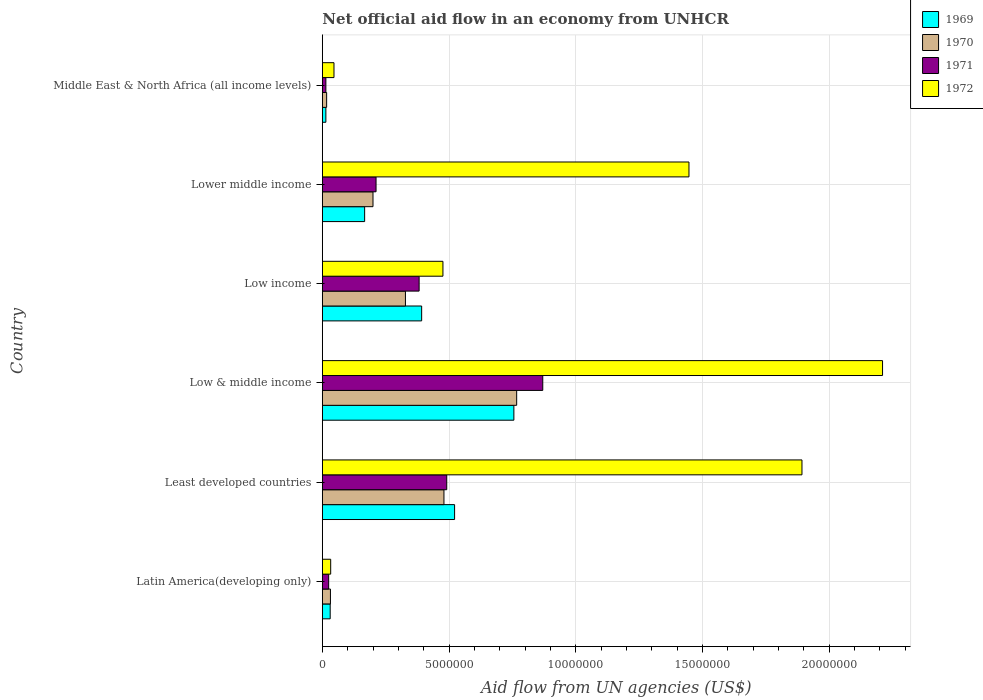How many different coloured bars are there?
Keep it short and to the point. 4. How many bars are there on the 6th tick from the bottom?
Give a very brief answer. 4. What is the label of the 1st group of bars from the top?
Your response must be concise. Middle East & North Africa (all income levels). In how many cases, is the number of bars for a given country not equal to the number of legend labels?
Offer a very short reply. 0. What is the net official aid flow in 1971 in Least developed countries?
Your response must be concise. 4.91e+06. Across all countries, what is the maximum net official aid flow in 1971?
Your answer should be very brief. 8.70e+06. In which country was the net official aid flow in 1972 maximum?
Ensure brevity in your answer.  Low & middle income. In which country was the net official aid flow in 1969 minimum?
Ensure brevity in your answer.  Middle East & North Africa (all income levels). What is the total net official aid flow in 1969 in the graph?
Keep it short and to the point. 1.88e+07. What is the difference between the net official aid flow in 1969 in Low & middle income and that in Lower middle income?
Make the answer very short. 5.89e+06. What is the difference between the net official aid flow in 1970 in Least developed countries and the net official aid flow in 1972 in Low & middle income?
Keep it short and to the point. -1.73e+07. What is the average net official aid flow in 1972 per country?
Ensure brevity in your answer.  1.02e+07. What is the difference between the net official aid flow in 1972 and net official aid flow in 1970 in Low income?
Offer a terse response. 1.48e+06. What is the ratio of the net official aid flow in 1969 in Low & middle income to that in Lower middle income?
Make the answer very short. 4.53. What is the difference between the highest and the second highest net official aid flow in 1971?
Provide a succinct answer. 3.79e+06. What is the difference between the highest and the lowest net official aid flow in 1970?
Provide a short and direct response. 7.50e+06. In how many countries, is the net official aid flow in 1971 greater than the average net official aid flow in 1971 taken over all countries?
Your answer should be very brief. 3. What does the 1st bar from the bottom in Lower middle income represents?
Give a very brief answer. 1969. Is it the case that in every country, the sum of the net official aid flow in 1970 and net official aid flow in 1971 is greater than the net official aid flow in 1969?
Your answer should be compact. Yes. How many bars are there?
Provide a succinct answer. 24. Are all the bars in the graph horizontal?
Provide a short and direct response. Yes. What is the difference between two consecutive major ticks on the X-axis?
Make the answer very short. 5.00e+06. Are the values on the major ticks of X-axis written in scientific E-notation?
Your answer should be very brief. No. Does the graph contain any zero values?
Ensure brevity in your answer.  No. How are the legend labels stacked?
Offer a very short reply. Vertical. What is the title of the graph?
Your answer should be very brief. Net official aid flow in an economy from UNHCR. What is the label or title of the X-axis?
Offer a terse response. Aid flow from UN agencies (US$). What is the label or title of the Y-axis?
Give a very brief answer. Country. What is the Aid flow from UN agencies (US$) in 1970 in Latin America(developing only)?
Your response must be concise. 3.20e+05. What is the Aid flow from UN agencies (US$) in 1971 in Latin America(developing only)?
Provide a succinct answer. 2.50e+05. What is the Aid flow from UN agencies (US$) of 1972 in Latin America(developing only)?
Give a very brief answer. 3.30e+05. What is the Aid flow from UN agencies (US$) in 1969 in Least developed countries?
Make the answer very short. 5.22e+06. What is the Aid flow from UN agencies (US$) of 1970 in Least developed countries?
Offer a terse response. 4.80e+06. What is the Aid flow from UN agencies (US$) of 1971 in Least developed countries?
Provide a short and direct response. 4.91e+06. What is the Aid flow from UN agencies (US$) in 1972 in Least developed countries?
Give a very brief answer. 1.89e+07. What is the Aid flow from UN agencies (US$) in 1969 in Low & middle income?
Your answer should be compact. 7.56e+06. What is the Aid flow from UN agencies (US$) of 1970 in Low & middle income?
Make the answer very short. 7.67e+06. What is the Aid flow from UN agencies (US$) in 1971 in Low & middle income?
Keep it short and to the point. 8.70e+06. What is the Aid flow from UN agencies (US$) of 1972 in Low & middle income?
Your answer should be compact. 2.21e+07. What is the Aid flow from UN agencies (US$) of 1969 in Low income?
Your answer should be very brief. 3.92e+06. What is the Aid flow from UN agencies (US$) of 1970 in Low income?
Make the answer very short. 3.28e+06. What is the Aid flow from UN agencies (US$) in 1971 in Low income?
Ensure brevity in your answer.  3.82e+06. What is the Aid flow from UN agencies (US$) in 1972 in Low income?
Ensure brevity in your answer.  4.76e+06. What is the Aid flow from UN agencies (US$) of 1969 in Lower middle income?
Offer a very short reply. 1.67e+06. What is the Aid flow from UN agencies (US$) in 1970 in Lower middle income?
Your answer should be compact. 2.00e+06. What is the Aid flow from UN agencies (US$) of 1971 in Lower middle income?
Make the answer very short. 2.12e+06. What is the Aid flow from UN agencies (US$) in 1972 in Lower middle income?
Your answer should be very brief. 1.45e+07. What is the Aid flow from UN agencies (US$) in 1969 in Middle East & North Africa (all income levels)?
Keep it short and to the point. 1.40e+05. What is the Aid flow from UN agencies (US$) of 1970 in Middle East & North Africa (all income levels)?
Your answer should be very brief. 1.70e+05. What is the Aid flow from UN agencies (US$) of 1972 in Middle East & North Africa (all income levels)?
Your answer should be compact. 4.60e+05. Across all countries, what is the maximum Aid flow from UN agencies (US$) of 1969?
Keep it short and to the point. 7.56e+06. Across all countries, what is the maximum Aid flow from UN agencies (US$) of 1970?
Your answer should be compact. 7.67e+06. Across all countries, what is the maximum Aid flow from UN agencies (US$) in 1971?
Offer a terse response. 8.70e+06. Across all countries, what is the maximum Aid flow from UN agencies (US$) of 1972?
Offer a terse response. 2.21e+07. Across all countries, what is the minimum Aid flow from UN agencies (US$) of 1969?
Offer a terse response. 1.40e+05. What is the total Aid flow from UN agencies (US$) of 1969 in the graph?
Provide a succinct answer. 1.88e+07. What is the total Aid flow from UN agencies (US$) in 1970 in the graph?
Your response must be concise. 1.82e+07. What is the total Aid flow from UN agencies (US$) of 1971 in the graph?
Keep it short and to the point. 1.99e+07. What is the total Aid flow from UN agencies (US$) in 1972 in the graph?
Offer a terse response. 6.11e+07. What is the difference between the Aid flow from UN agencies (US$) of 1969 in Latin America(developing only) and that in Least developed countries?
Provide a succinct answer. -4.91e+06. What is the difference between the Aid flow from UN agencies (US$) in 1970 in Latin America(developing only) and that in Least developed countries?
Your response must be concise. -4.48e+06. What is the difference between the Aid flow from UN agencies (US$) in 1971 in Latin America(developing only) and that in Least developed countries?
Your response must be concise. -4.66e+06. What is the difference between the Aid flow from UN agencies (US$) in 1972 in Latin America(developing only) and that in Least developed countries?
Ensure brevity in your answer.  -1.86e+07. What is the difference between the Aid flow from UN agencies (US$) of 1969 in Latin America(developing only) and that in Low & middle income?
Give a very brief answer. -7.25e+06. What is the difference between the Aid flow from UN agencies (US$) in 1970 in Latin America(developing only) and that in Low & middle income?
Give a very brief answer. -7.35e+06. What is the difference between the Aid flow from UN agencies (US$) of 1971 in Latin America(developing only) and that in Low & middle income?
Provide a short and direct response. -8.45e+06. What is the difference between the Aid flow from UN agencies (US$) in 1972 in Latin America(developing only) and that in Low & middle income?
Provide a short and direct response. -2.18e+07. What is the difference between the Aid flow from UN agencies (US$) of 1969 in Latin America(developing only) and that in Low income?
Your response must be concise. -3.61e+06. What is the difference between the Aid flow from UN agencies (US$) of 1970 in Latin America(developing only) and that in Low income?
Ensure brevity in your answer.  -2.96e+06. What is the difference between the Aid flow from UN agencies (US$) in 1971 in Latin America(developing only) and that in Low income?
Keep it short and to the point. -3.57e+06. What is the difference between the Aid flow from UN agencies (US$) in 1972 in Latin America(developing only) and that in Low income?
Provide a short and direct response. -4.43e+06. What is the difference between the Aid flow from UN agencies (US$) in 1969 in Latin America(developing only) and that in Lower middle income?
Give a very brief answer. -1.36e+06. What is the difference between the Aid flow from UN agencies (US$) of 1970 in Latin America(developing only) and that in Lower middle income?
Give a very brief answer. -1.68e+06. What is the difference between the Aid flow from UN agencies (US$) of 1971 in Latin America(developing only) and that in Lower middle income?
Offer a terse response. -1.87e+06. What is the difference between the Aid flow from UN agencies (US$) in 1972 in Latin America(developing only) and that in Lower middle income?
Make the answer very short. -1.41e+07. What is the difference between the Aid flow from UN agencies (US$) of 1969 in Latin America(developing only) and that in Middle East & North Africa (all income levels)?
Offer a terse response. 1.70e+05. What is the difference between the Aid flow from UN agencies (US$) of 1970 in Latin America(developing only) and that in Middle East & North Africa (all income levels)?
Ensure brevity in your answer.  1.50e+05. What is the difference between the Aid flow from UN agencies (US$) of 1971 in Latin America(developing only) and that in Middle East & North Africa (all income levels)?
Ensure brevity in your answer.  1.10e+05. What is the difference between the Aid flow from UN agencies (US$) in 1969 in Least developed countries and that in Low & middle income?
Keep it short and to the point. -2.34e+06. What is the difference between the Aid flow from UN agencies (US$) of 1970 in Least developed countries and that in Low & middle income?
Your answer should be compact. -2.87e+06. What is the difference between the Aid flow from UN agencies (US$) in 1971 in Least developed countries and that in Low & middle income?
Provide a succinct answer. -3.79e+06. What is the difference between the Aid flow from UN agencies (US$) of 1972 in Least developed countries and that in Low & middle income?
Offer a very short reply. -3.18e+06. What is the difference between the Aid flow from UN agencies (US$) of 1969 in Least developed countries and that in Low income?
Provide a short and direct response. 1.30e+06. What is the difference between the Aid flow from UN agencies (US$) of 1970 in Least developed countries and that in Low income?
Offer a terse response. 1.52e+06. What is the difference between the Aid flow from UN agencies (US$) of 1971 in Least developed countries and that in Low income?
Give a very brief answer. 1.09e+06. What is the difference between the Aid flow from UN agencies (US$) of 1972 in Least developed countries and that in Low income?
Your response must be concise. 1.42e+07. What is the difference between the Aid flow from UN agencies (US$) in 1969 in Least developed countries and that in Lower middle income?
Keep it short and to the point. 3.55e+06. What is the difference between the Aid flow from UN agencies (US$) in 1970 in Least developed countries and that in Lower middle income?
Offer a terse response. 2.80e+06. What is the difference between the Aid flow from UN agencies (US$) in 1971 in Least developed countries and that in Lower middle income?
Offer a very short reply. 2.79e+06. What is the difference between the Aid flow from UN agencies (US$) of 1972 in Least developed countries and that in Lower middle income?
Give a very brief answer. 4.46e+06. What is the difference between the Aid flow from UN agencies (US$) in 1969 in Least developed countries and that in Middle East & North Africa (all income levels)?
Make the answer very short. 5.08e+06. What is the difference between the Aid flow from UN agencies (US$) of 1970 in Least developed countries and that in Middle East & North Africa (all income levels)?
Offer a very short reply. 4.63e+06. What is the difference between the Aid flow from UN agencies (US$) in 1971 in Least developed countries and that in Middle East & North Africa (all income levels)?
Keep it short and to the point. 4.77e+06. What is the difference between the Aid flow from UN agencies (US$) of 1972 in Least developed countries and that in Middle East & North Africa (all income levels)?
Your answer should be compact. 1.85e+07. What is the difference between the Aid flow from UN agencies (US$) of 1969 in Low & middle income and that in Low income?
Your answer should be compact. 3.64e+06. What is the difference between the Aid flow from UN agencies (US$) in 1970 in Low & middle income and that in Low income?
Your answer should be compact. 4.39e+06. What is the difference between the Aid flow from UN agencies (US$) of 1971 in Low & middle income and that in Low income?
Give a very brief answer. 4.88e+06. What is the difference between the Aid flow from UN agencies (US$) in 1972 in Low & middle income and that in Low income?
Provide a succinct answer. 1.74e+07. What is the difference between the Aid flow from UN agencies (US$) of 1969 in Low & middle income and that in Lower middle income?
Your answer should be very brief. 5.89e+06. What is the difference between the Aid flow from UN agencies (US$) in 1970 in Low & middle income and that in Lower middle income?
Keep it short and to the point. 5.67e+06. What is the difference between the Aid flow from UN agencies (US$) of 1971 in Low & middle income and that in Lower middle income?
Your response must be concise. 6.58e+06. What is the difference between the Aid flow from UN agencies (US$) in 1972 in Low & middle income and that in Lower middle income?
Your answer should be very brief. 7.64e+06. What is the difference between the Aid flow from UN agencies (US$) of 1969 in Low & middle income and that in Middle East & North Africa (all income levels)?
Give a very brief answer. 7.42e+06. What is the difference between the Aid flow from UN agencies (US$) of 1970 in Low & middle income and that in Middle East & North Africa (all income levels)?
Your answer should be compact. 7.50e+06. What is the difference between the Aid flow from UN agencies (US$) in 1971 in Low & middle income and that in Middle East & North Africa (all income levels)?
Ensure brevity in your answer.  8.56e+06. What is the difference between the Aid flow from UN agencies (US$) in 1972 in Low & middle income and that in Middle East & North Africa (all income levels)?
Keep it short and to the point. 2.16e+07. What is the difference between the Aid flow from UN agencies (US$) of 1969 in Low income and that in Lower middle income?
Your answer should be compact. 2.25e+06. What is the difference between the Aid flow from UN agencies (US$) in 1970 in Low income and that in Lower middle income?
Offer a very short reply. 1.28e+06. What is the difference between the Aid flow from UN agencies (US$) of 1971 in Low income and that in Lower middle income?
Provide a succinct answer. 1.70e+06. What is the difference between the Aid flow from UN agencies (US$) of 1972 in Low income and that in Lower middle income?
Give a very brief answer. -9.71e+06. What is the difference between the Aid flow from UN agencies (US$) in 1969 in Low income and that in Middle East & North Africa (all income levels)?
Provide a short and direct response. 3.78e+06. What is the difference between the Aid flow from UN agencies (US$) in 1970 in Low income and that in Middle East & North Africa (all income levels)?
Your answer should be very brief. 3.11e+06. What is the difference between the Aid flow from UN agencies (US$) in 1971 in Low income and that in Middle East & North Africa (all income levels)?
Provide a short and direct response. 3.68e+06. What is the difference between the Aid flow from UN agencies (US$) of 1972 in Low income and that in Middle East & North Africa (all income levels)?
Your response must be concise. 4.30e+06. What is the difference between the Aid flow from UN agencies (US$) of 1969 in Lower middle income and that in Middle East & North Africa (all income levels)?
Your response must be concise. 1.53e+06. What is the difference between the Aid flow from UN agencies (US$) of 1970 in Lower middle income and that in Middle East & North Africa (all income levels)?
Your answer should be compact. 1.83e+06. What is the difference between the Aid flow from UN agencies (US$) in 1971 in Lower middle income and that in Middle East & North Africa (all income levels)?
Your response must be concise. 1.98e+06. What is the difference between the Aid flow from UN agencies (US$) of 1972 in Lower middle income and that in Middle East & North Africa (all income levels)?
Your answer should be compact. 1.40e+07. What is the difference between the Aid flow from UN agencies (US$) of 1969 in Latin America(developing only) and the Aid flow from UN agencies (US$) of 1970 in Least developed countries?
Your answer should be compact. -4.49e+06. What is the difference between the Aid flow from UN agencies (US$) of 1969 in Latin America(developing only) and the Aid flow from UN agencies (US$) of 1971 in Least developed countries?
Provide a succinct answer. -4.60e+06. What is the difference between the Aid flow from UN agencies (US$) of 1969 in Latin America(developing only) and the Aid flow from UN agencies (US$) of 1972 in Least developed countries?
Your answer should be compact. -1.86e+07. What is the difference between the Aid flow from UN agencies (US$) in 1970 in Latin America(developing only) and the Aid flow from UN agencies (US$) in 1971 in Least developed countries?
Your response must be concise. -4.59e+06. What is the difference between the Aid flow from UN agencies (US$) of 1970 in Latin America(developing only) and the Aid flow from UN agencies (US$) of 1972 in Least developed countries?
Your answer should be compact. -1.86e+07. What is the difference between the Aid flow from UN agencies (US$) of 1971 in Latin America(developing only) and the Aid flow from UN agencies (US$) of 1972 in Least developed countries?
Make the answer very short. -1.87e+07. What is the difference between the Aid flow from UN agencies (US$) in 1969 in Latin America(developing only) and the Aid flow from UN agencies (US$) in 1970 in Low & middle income?
Provide a short and direct response. -7.36e+06. What is the difference between the Aid flow from UN agencies (US$) of 1969 in Latin America(developing only) and the Aid flow from UN agencies (US$) of 1971 in Low & middle income?
Give a very brief answer. -8.39e+06. What is the difference between the Aid flow from UN agencies (US$) in 1969 in Latin America(developing only) and the Aid flow from UN agencies (US$) in 1972 in Low & middle income?
Provide a succinct answer. -2.18e+07. What is the difference between the Aid flow from UN agencies (US$) in 1970 in Latin America(developing only) and the Aid flow from UN agencies (US$) in 1971 in Low & middle income?
Offer a very short reply. -8.38e+06. What is the difference between the Aid flow from UN agencies (US$) in 1970 in Latin America(developing only) and the Aid flow from UN agencies (US$) in 1972 in Low & middle income?
Make the answer very short. -2.18e+07. What is the difference between the Aid flow from UN agencies (US$) of 1971 in Latin America(developing only) and the Aid flow from UN agencies (US$) of 1972 in Low & middle income?
Offer a very short reply. -2.19e+07. What is the difference between the Aid flow from UN agencies (US$) in 1969 in Latin America(developing only) and the Aid flow from UN agencies (US$) in 1970 in Low income?
Keep it short and to the point. -2.97e+06. What is the difference between the Aid flow from UN agencies (US$) of 1969 in Latin America(developing only) and the Aid flow from UN agencies (US$) of 1971 in Low income?
Give a very brief answer. -3.51e+06. What is the difference between the Aid flow from UN agencies (US$) of 1969 in Latin America(developing only) and the Aid flow from UN agencies (US$) of 1972 in Low income?
Offer a terse response. -4.45e+06. What is the difference between the Aid flow from UN agencies (US$) of 1970 in Latin America(developing only) and the Aid flow from UN agencies (US$) of 1971 in Low income?
Your response must be concise. -3.50e+06. What is the difference between the Aid flow from UN agencies (US$) in 1970 in Latin America(developing only) and the Aid flow from UN agencies (US$) in 1972 in Low income?
Your response must be concise. -4.44e+06. What is the difference between the Aid flow from UN agencies (US$) of 1971 in Latin America(developing only) and the Aid flow from UN agencies (US$) of 1972 in Low income?
Keep it short and to the point. -4.51e+06. What is the difference between the Aid flow from UN agencies (US$) of 1969 in Latin America(developing only) and the Aid flow from UN agencies (US$) of 1970 in Lower middle income?
Give a very brief answer. -1.69e+06. What is the difference between the Aid flow from UN agencies (US$) of 1969 in Latin America(developing only) and the Aid flow from UN agencies (US$) of 1971 in Lower middle income?
Your answer should be compact. -1.81e+06. What is the difference between the Aid flow from UN agencies (US$) of 1969 in Latin America(developing only) and the Aid flow from UN agencies (US$) of 1972 in Lower middle income?
Your response must be concise. -1.42e+07. What is the difference between the Aid flow from UN agencies (US$) of 1970 in Latin America(developing only) and the Aid flow from UN agencies (US$) of 1971 in Lower middle income?
Your answer should be compact. -1.80e+06. What is the difference between the Aid flow from UN agencies (US$) of 1970 in Latin America(developing only) and the Aid flow from UN agencies (US$) of 1972 in Lower middle income?
Your response must be concise. -1.42e+07. What is the difference between the Aid flow from UN agencies (US$) in 1971 in Latin America(developing only) and the Aid flow from UN agencies (US$) in 1972 in Lower middle income?
Your answer should be very brief. -1.42e+07. What is the difference between the Aid flow from UN agencies (US$) of 1969 in Latin America(developing only) and the Aid flow from UN agencies (US$) of 1970 in Middle East & North Africa (all income levels)?
Your answer should be very brief. 1.40e+05. What is the difference between the Aid flow from UN agencies (US$) of 1969 in Latin America(developing only) and the Aid flow from UN agencies (US$) of 1971 in Middle East & North Africa (all income levels)?
Ensure brevity in your answer.  1.70e+05. What is the difference between the Aid flow from UN agencies (US$) in 1969 in Latin America(developing only) and the Aid flow from UN agencies (US$) in 1972 in Middle East & North Africa (all income levels)?
Your response must be concise. -1.50e+05. What is the difference between the Aid flow from UN agencies (US$) in 1970 in Latin America(developing only) and the Aid flow from UN agencies (US$) in 1971 in Middle East & North Africa (all income levels)?
Provide a short and direct response. 1.80e+05. What is the difference between the Aid flow from UN agencies (US$) in 1970 in Latin America(developing only) and the Aid flow from UN agencies (US$) in 1972 in Middle East & North Africa (all income levels)?
Offer a very short reply. -1.40e+05. What is the difference between the Aid flow from UN agencies (US$) in 1971 in Latin America(developing only) and the Aid flow from UN agencies (US$) in 1972 in Middle East & North Africa (all income levels)?
Make the answer very short. -2.10e+05. What is the difference between the Aid flow from UN agencies (US$) in 1969 in Least developed countries and the Aid flow from UN agencies (US$) in 1970 in Low & middle income?
Ensure brevity in your answer.  -2.45e+06. What is the difference between the Aid flow from UN agencies (US$) of 1969 in Least developed countries and the Aid flow from UN agencies (US$) of 1971 in Low & middle income?
Offer a very short reply. -3.48e+06. What is the difference between the Aid flow from UN agencies (US$) in 1969 in Least developed countries and the Aid flow from UN agencies (US$) in 1972 in Low & middle income?
Keep it short and to the point. -1.69e+07. What is the difference between the Aid flow from UN agencies (US$) of 1970 in Least developed countries and the Aid flow from UN agencies (US$) of 1971 in Low & middle income?
Provide a short and direct response. -3.90e+06. What is the difference between the Aid flow from UN agencies (US$) in 1970 in Least developed countries and the Aid flow from UN agencies (US$) in 1972 in Low & middle income?
Ensure brevity in your answer.  -1.73e+07. What is the difference between the Aid flow from UN agencies (US$) of 1971 in Least developed countries and the Aid flow from UN agencies (US$) of 1972 in Low & middle income?
Provide a short and direct response. -1.72e+07. What is the difference between the Aid flow from UN agencies (US$) in 1969 in Least developed countries and the Aid flow from UN agencies (US$) in 1970 in Low income?
Your response must be concise. 1.94e+06. What is the difference between the Aid flow from UN agencies (US$) in 1969 in Least developed countries and the Aid flow from UN agencies (US$) in 1971 in Low income?
Offer a very short reply. 1.40e+06. What is the difference between the Aid flow from UN agencies (US$) in 1970 in Least developed countries and the Aid flow from UN agencies (US$) in 1971 in Low income?
Offer a very short reply. 9.80e+05. What is the difference between the Aid flow from UN agencies (US$) of 1971 in Least developed countries and the Aid flow from UN agencies (US$) of 1972 in Low income?
Provide a short and direct response. 1.50e+05. What is the difference between the Aid flow from UN agencies (US$) in 1969 in Least developed countries and the Aid flow from UN agencies (US$) in 1970 in Lower middle income?
Offer a very short reply. 3.22e+06. What is the difference between the Aid flow from UN agencies (US$) of 1969 in Least developed countries and the Aid flow from UN agencies (US$) of 1971 in Lower middle income?
Offer a very short reply. 3.10e+06. What is the difference between the Aid flow from UN agencies (US$) in 1969 in Least developed countries and the Aid flow from UN agencies (US$) in 1972 in Lower middle income?
Provide a succinct answer. -9.25e+06. What is the difference between the Aid flow from UN agencies (US$) of 1970 in Least developed countries and the Aid flow from UN agencies (US$) of 1971 in Lower middle income?
Ensure brevity in your answer.  2.68e+06. What is the difference between the Aid flow from UN agencies (US$) of 1970 in Least developed countries and the Aid flow from UN agencies (US$) of 1972 in Lower middle income?
Offer a terse response. -9.67e+06. What is the difference between the Aid flow from UN agencies (US$) of 1971 in Least developed countries and the Aid flow from UN agencies (US$) of 1972 in Lower middle income?
Make the answer very short. -9.56e+06. What is the difference between the Aid flow from UN agencies (US$) of 1969 in Least developed countries and the Aid flow from UN agencies (US$) of 1970 in Middle East & North Africa (all income levels)?
Your answer should be compact. 5.05e+06. What is the difference between the Aid flow from UN agencies (US$) of 1969 in Least developed countries and the Aid flow from UN agencies (US$) of 1971 in Middle East & North Africa (all income levels)?
Give a very brief answer. 5.08e+06. What is the difference between the Aid flow from UN agencies (US$) of 1969 in Least developed countries and the Aid flow from UN agencies (US$) of 1972 in Middle East & North Africa (all income levels)?
Give a very brief answer. 4.76e+06. What is the difference between the Aid flow from UN agencies (US$) in 1970 in Least developed countries and the Aid flow from UN agencies (US$) in 1971 in Middle East & North Africa (all income levels)?
Keep it short and to the point. 4.66e+06. What is the difference between the Aid flow from UN agencies (US$) of 1970 in Least developed countries and the Aid flow from UN agencies (US$) of 1972 in Middle East & North Africa (all income levels)?
Your answer should be very brief. 4.34e+06. What is the difference between the Aid flow from UN agencies (US$) in 1971 in Least developed countries and the Aid flow from UN agencies (US$) in 1972 in Middle East & North Africa (all income levels)?
Provide a short and direct response. 4.45e+06. What is the difference between the Aid flow from UN agencies (US$) in 1969 in Low & middle income and the Aid flow from UN agencies (US$) in 1970 in Low income?
Your answer should be very brief. 4.28e+06. What is the difference between the Aid flow from UN agencies (US$) of 1969 in Low & middle income and the Aid flow from UN agencies (US$) of 1971 in Low income?
Keep it short and to the point. 3.74e+06. What is the difference between the Aid flow from UN agencies (US$) in 1969 in Low & middle income and the Aid flow from UN agencies (US$) in 1972 in Low income?
Make the answer very short. 2.80e+06. What is the difference between the Aid flow from UN agencies (US$) in 1970 in Low & middle income and the Aid flow from UN agencies (US$) in 1971 in Low income?
Your response must be concise. 3.85e+06. What is the difference between the Aid flow from UN agencies (US$) in 1970 in Low & middle income and the Aid flow from UN agencies (US$) in 1972 in Low income?
Offer a terse response. 2.91e+06. What is the difference between the Aid flow from UN agencies (US$) in 1971 in Low & middle income and the Aid flow from UN agencies (US$) in 1972 in Low income?
Provide a succinct answer. 3.94e+06. What is the difference between the Aid flow from UN agencies (US$) of 1969 in Low & middle income and the Aid flow from UN agencies (US$) of 1970 in Lower middle income?
Offer a terse response. 5.56e+06. What is the difference between the Aid flow from UN agencies (US$) of 1969 in Low & middle income and the Aid flow from UN agencies (US$) of 1971 in Lower middle income?
Provide a succinct answer. 5.44e+06. What is the difference between the Aid flow from UN agencies (US$) of 1969 in Low & middle income and the Aid flow from UN agencies (US$) of 1972 in Lower middle income?
Keep it short and to the point. -6.91e+06. What is the difference between the Aid flow from UN agencies (US$) in 1970 in Low & middle income and the Aid flow from UN agencies (US$) in 1971 in Lower middle income?
Make the answer very short. 5.55e+06. What is the difference between the Aid flow from UN agencies (US$) of 1970 in Low & middle income and the Aid flow from UN agencies (US$) of 1972 in Lower middle income?
Provide a succinct answer. -6.80e+06. What is the difference between the Aid flow from UN agencies (US$) in 1971 in Low & middle income and the Aid flow from UN agencies (US$) in 1972 in Lower middle income?
Provide a succinct answer. -5.77e+06. What is the difference between the Aid flow from UN agencies (US$) of 1969 in Low & middle income and the Aid flow from UN agencies (US$) of 1970 in Middle East & North Africa (all income levels)?
Provide a succinct answer. 7.39e+06. What is the difference between the Aid flow from UN agencies (US$) in 1969 in Low & middle income and the Aid flow from UN agencies (US$) in 1971 in Middle East & North Africa (all income levels)?
Ensure brevity in your answer.  7.42e+06. What is the difference between the Aid flow from UN agencies (US$) in 1969 in Low & middle income and the Aid flow from UN agencies (US$) in 1972 in Middle East & North Africa (all income levels)?
Offer a terse response. 7.10e+06. What is the difference between the Aid flow from UN agencies (US$) of 1970 in Low & middle income and the Aid flow from UN agencies (US$) of 1971 in Middle East & North Africa (all income levels)?
Keep it short and to the point. 7.53e+06. What is the difference between the Aid flow from UN agencies (US$) of 1970 in Low & middle income and the Aid flow from UN agencies (US$) of 1972 in Middle East & North Africa (all income levels)?
Your answer should be compact. 7.21e+06. What is the difference between the Aid flow from UN agencies (US$) of 1971 in Low & middle income and the Aid flow from UN agencies (US$) of 1972 in Middle East & North Africa (all income levels)?
Offer a very short reply. 8.24e+06. What is the difference between the Aid flow from UN agencies (US$) in 1969 in Low income and the Aid flow from UN agencies (US$) in 1970 in Lower middle income?
Offer a very short reply. 1.92e+06. What is the difference between the Aid flow from UN agencies (US$) in 1969 in Low income and the Aid flow from UN agencies (US$) in 1971 in Lower middle income?
Keep it short and to the point. 1.80e+06. What is the difference between the Aid flow from UN agencies (US$) of 1969 in Low income and the Aid flow from UN agencies (US$) of 1972 in Lower middle income?
Your answer should be very brief. -1.06e+07. What is the difference between the Aid flow from UN agencies (US$) of 1970 in Low income and the Aid flow from UN agencies (US$) of 1971 in Lower middle income?
Your answer should be very brief. 1.16e+06. What is the difference between the Aid flow from UN agencies (US$) in 1970 in Low income and the Aid flow from UN agencies (US$) in 1972 in Lower middle income?
Keep it short and to the point. -1.12e+07. What is the difference between the Aid flow from UN agencies (US$) of 1971 in Low income and the Aid flow from UN agencies (US$) of 1972 in Lower middle income?
Provide a short and direct response. -1.06e+07. What is the difference between the Aid flow from UN agencies (US$) in 1969 in Low income and the Aid flow from UN agencies (US$) in 1970 in Middle East & North Africa (all income levels)?
Keep it short and to the point. 3.75e+06. What is the difference between the Aid flow from UN agencies (US$) of 1969 in Low income and the Aid flow from UN agencies (US$) of 1971 in Middle East & North Africa (all income levels)?
Provide a short and direct response. 3.78e+06. What is the difference between the Aid flow from UN agencies (US$) of 1969 in Low income and the Aid flow from UN agencies (US$) of 1972 in Middle East & North Africa (all income levels)?
Keep it short and to the point. 3.46e+06. What is the difference between the Aid flow from UN agencies (US$) in 1970 in Low income and the Aid flow from UN agencies (US$) in 1971 in Middle East & North Africa (all income levels)?
Your answer should be very brief. 3.14e+06. What is the difference between the Aid flow from UN agencies (US$) of 1970 in Low income and the Aid flow from UN agencies (US$) of 1972 in Middle East & North Africa (all income levels)?
Your answer should be very brief. 2.82e+06. What is the difference between the Aid flow from UN agencies (US$) of 1971 in Low income and the Aid flow from UN agencies (US$) of 1972 in Middle East & North Africa (all income levels)?
Your answer should be very brief. 3.36e+06. What is the difference between the Aid flow from UN agencies (US$) of 1969 in Lower middle income and the Aid flow from UN agencies (US$) of 1970 in Middle East & North Africa (all income levels)?
Ensure brevity in your answer.  1.50e+06. What is the difference between the Aid flow from UN agencies (US$) in 1969 in Lower middle income and the Aid flow from UN agencies (US$) in 1971 in Middle East & North Africa (all income levels)?
Provide a short and direct response. 1.53e+06. What is the difference between the Aid flow from UN agencies (US$) of 1969 in Lower middle income and the Aid flow from UN agencies (US$) of 1972 in Middle East & North Africa (all income levels)?
Give a very brief answer. 1.21e+06. What is the difference between the Aid flow from UN agencies (US$) of 1970 in Lower middle income and the Aid flow from UN agencies (US$) of 1971 in Middle East & North Africa (all income levels)?
Provide a succinct answer. 1.86e+06. What is the difference between the Aid flow from UN agencies (US$) of 1970 in Lower middle income and the Aid flow from UN agencies (US$) of 1972 in Middle East & North Africa (all income levels)?
Provide a succinct answer. 1.54e+06. What is the difference between the Aid flow from UN agencies (US$) of 1971 in Lower middle income and the Aid flow from UN agencies (US$) of 1972 in Middle East & North Africa (all income levels)?
Give a very brief answer. 1.66e+06. What is the average Aid flow from UN agencies (US$) of 1969 per country?
Give a very brief answer. 3.14e+06. What is the average Aid flow from UN agencies (US$) in 1970 per country?
Make the answer very short. 3.04e+06. What is the average Aid flow from UN agencies (US$) of 1971 per country?
Your answer should be compact. 3.32e+06. What is the average Aid flow from UN agencies (US$) of 1972 per country?
Give a very brief answer. 1.02e+07. What is the difference between the Aid flow from UN agencies (US$) of 1969 and Aid flow from UN agencies (US$) of 1970 in Latin America(developing only)?
Your answer should be very brief. -10000. What is the difference between the Aid flow from UN agencies (US$) of 1970 and Aid flow from UN agencies (US$) of 1971 in Latin America(developing only)?
Your response must be concise. 7.00e+04. What is the difference between the Aid flow from UN agencies (US$) of 1970 and Aid flow from UN agencies (US$) of 1972 in Latin America(developing only)?
Provide a succinct answer. -10000. What is the difference between the Aid flow from UN agencies (US$) of 1969 and Aid flow from UN agencies (US$) of 1971 in Least developed countries?
Ensure brevity in your answer.  3.10e+05. What is the difference between the Aid flow from UN agencies (US$) in 1969 and Aid flow from UN agencies (US$) in 1972 in Least developed countries?
Make the answer very short. -1.37e+07. What is the difference between the Aid flow from UN agencies (US$) of 1970 and Aid flow from UN agencies (US$) of 1972 in Least developed countries?
Your response must be concise. -1.41e+07. What is the difference between the Aid flow from UN agencies (US$) in 1971 and Aid flow from UN agencies (US$) in 1972 in Least developed countries?
Your response must be concise. -1.40e+07. What is the difference between the Aid flow from UN agencies (US$) in 1969 and Aid flow from UN agencies (US$) in 1971 in Low & middle income?
Give a very brief answer. -1.14e+06. What is the difference between the Aid flow from UN agencies (US$) in 1969 and Aid flow from UN agencies (US$) in 1972 in Low & middle income?
Your response must be concise. -1.46e+07. What is the difference between the Aid flow from UN agencies (US$) of 1970 and Aid flow from UN agencies (US$) of 1971 in Low & middle income?
Offer a very short reply. -1.03e+06. What is the difference between the Aid flow from UN agencies (US$) of 1970 and Aid flow from UN agencies (US$) of 1972 in Low & middle income?
Give a very brief answer. -1.44e+07. What is the difference between the Aid flow from UN agencies (US$) in 1971 and Aid flow from UN agencies (US$) in 1972 in Low & middle income?
Provide a short and direct response. -1.34e+07. What is the difference between the Aid flow from UN agencies (US$) of 1969 and Aid flow from UN agencies (US$) of 1970 in Low income?
Provide a short and direct response. 6.40e+05. What is the difference between the Aid flow from UN agencies (US$) of 1969 and Aid flow from UN agencies (US$) of 1972 in Low income?
Your answer should be very brief. -8.40e+05. What is the difference between the Aid flow from UN agencies (US$) of 1970 and Aid flow from UN agencies (US$) of 1971 in Low income?
Your answer should be very brief. -5.40e+05. What is the difference between the Aid flow from UN agencies (US$) in 1970 and Aid flow from UN agencies (US$) in 1972 in Low income?
Your answer should be very brief. -1.48e+06. What is the difference between the Aid flow from UN agencies (US$) of 1971 and Aid flow from UN agencies (US$) of 1972 in Low income?
Your response must be concise. -9.40e+05. What is the difference between the Aid flow from UN agencies (US$) of 1969 and Aid flow from UN agencies (US$) of 1970 in Lower middle income?
Ensure brevity in your answer.  -3.30e+05. What is the difference between the Aid flow from UN agencies (US$) of 1969 and Aid flow from UN agencies (US$) of 1971 in Lower middle income?
Your answer should be compact. -4.50e+05. What is the difference between the Aid flow from UN agencies (US$) of 1969 and Aid flow from UN agencies (US$) of 1972 in Lower middle income?
Give a very brief answer. -1.28e+07. What is the difference between the Aid flow from UN agencies (US$) in 1970 and Aid flow from UN agencies (US$) in 1971 in Lower middle income?
Provide a succinct answer. -1.20e+05. What is the difference between the Aid flow from UN agencies (US$) of 1970 and Aid flow from UN agencies (US$) of 1972 in Lower middle income?
Your answer should be very brief. -1.25e+07. What is the difference between the Aid flow from UN agencies (US$) in 1971 and Aid flow from UN agencies (US$) in 1972 in Lower middle income?
Make the answer very short. -1.24e+07. What is the difference between the Aid flow from UN agencies (US$) in 1969 and Aid flow from UN agencies (US$) in 1970 in Middle East & North Africa (all income levels)?
Keep it short and to the point. -3.00e+04. What is the difference between the Aid flow from UN agencies (US$) of 1969 and Aid flow from UN agencies (US$) of 1972 in Middle East & North Africa (all income levels)?
Provide a short and direct response. -3.20e+05. What is the difference between the Aid flow from UN agencies (US$) in 1970 and Aid flow from UN agencies (US$) in 1971 in Middle East & North Africa (all income levels)?
Provide a succinct answer. 3.00e+04. What is the difference between the Aid flow from UN agencies (US$) in 1971 and Aid flow from UN agencies (US$) in 1972 in Middle East & North Africa (all income levels)?
Your answer should be compact. -3.20e+05. What is the ratio of the Aid flow from UN agencies (US$) of 1969 in Latin America(developing only) to that in Least developed countries?
Give a very brief answer. 0.06. What is the ratio of the Aid flow from UN agencies (US$) in 1970 in Latin America(developing only) to that in Least developed countries?
Your answer should be compact. 0.07. What is the ratio of the Aid flow from UN agencies (US$) of 1971 in Latin America(developing only) to that in Least developed countries?
Your answer should be very brief. 0.05. What is the ratio of the Aid flow from UN agencies (US$) of 1972 in Latin America(developing only) to that in Least developed countries?
Offer a very short reply. 0.02. What is the ratio of the Aid flow from UN agencies (US$) in 1969 in Latin America(developing only) to that in Low & middle income?
Keep it short and to the point. 0.04. What is the ratio of the Aid flow from UN agencies (US$) in 1970 in Latin America(developing only) to that in Low & middle income?
Keep it short and to the point. 0.04. What is the ratio of the Aid flow from UN agencies (US$) in 1971 in Latin America(developing only) to that in Low & middle income?
Your response must be concise. 0.03. What is the ratio of the Aid flow from UN agencies (US$) of 1972 in Latin America(developing only) to that in Low & middle income?
Give a very brief answer. 0.01. What is the ratio of the Aid flow from UN agencies (US$) of 1969 in Latin America(developing only) to that in Low income?
Make the answer very short. 0.08. What is the ratio of the Aid flow from UN agencies (US$) in 1970 in Latin America(developing only) to that in Low income?
Provide a succinct answer. 0.1. What is the ratio of the Aid flow from UN agencies (US$) of 1971 in Latin America(developing only) to that in Low income?
Your answer should be compact. 0.07. What is the ratio of the Aid flow from UN agencies (US$) of 1972 in Latin America(developing only) to that in Low income?
Offer a very short reply. 0.07. What is the ratio of the Aid flow from UN agencies (US$) of 1969 in Latin America(developing only) to that in Lower middle income?
Make the answer very short. 0.19. What is the ratio of the Aid flow from UN agencies (US$) of 1970 in Latin America(developing only) to that in Lower middle income?
Keep it short and to the point. 0.16. What is the ratio of the Aid flow from UN agencies (US$) in 1971 in Latin America(developing only) to that in Lower middle income?
Provide a short and direct response. 0.12. What is the ratio of the Aid flow from UN agencies (US$) in 1972 in Latin America(developing only) to that in Lower middle income?
Offer a very short reply. 0.02. What is the ratio of the Aid flow from UN agencies (US$) of 1969 in Latin America(developing only) to that in Middle East & North Africa (all income levels)?
Provide a succinct answer. 2.21. What is the ratio of the Aid flow from UN agencies (US$) in 1970 in Latin America(developing only) to that in Middle East & North Africa (all income levels)?
Your response must be concise. 1.88. What is the ratio of the Aid flow from UN agencies (US$) in 1971 in Latin America(developing only) to that in Middle East & North Africa (all income levels)?
Give a very brief answer. 1.79. What is the ratio of the Aid flow from UN agencies (US$) of 1972 in Latin America(developing only) to that in Middle East & North Africa (all income levels)?
Give a very brief answer. 0.72. What is the ratio of the Aid flow from UN agencies (US$) in 1969 in Least developed countries to that in Low & middle income?
Make the answer very short. 0.69. What is the ratio of the Aid flow from UN agencies (US$) of 1970 in Least developed countries to that in Low & middle income?
Ensure brevity in your answer.  0.63. What is the ratio of the Aid flow from UN agencies (US$) in 1971 in Least developed countries to that in Low & middle income?
Ensure brevity in your answer.  0.56. What is the ratio of the Aid flow from UN agencies (US$) of 1972 in Least developed countries to that in Low & middle income?
Provide a short and direct response. 0.86. What is the ratio of the Aid flow from UN agencies (US$) of 1969 in Least developed countries to that in Low income?
Offer a terse response. 1.33. What is the ratio of the Aid flow from UN agencies (US$) in 1970 in Least developed countries to that in Low income?
Keep it short and to the point. 1.46. What is the ratio of the Aid flow from UN agencies (US$) of 1971 in Least developed countries to that in Low income?
Provide a short and direct response. 1.29. What is the ratio of the Aid flow from UN agencies (US$) in 1972 in Least developed countries to that in Low income?
Keep it short and to the point. 3.98. What is the ratio of the Aid flow from UN agencies (US$) of 1969 in Least developed countries to that in Lower middle income?
Keep it short and to the point. 3.13. What is the ratio of the Aid flow from UN agencies (US$) in 1971 in Least developed countries to that in Lower middle income?
Give a very brief answer. 2.32. What is the ratio of the Aid flow from UN agencies (US$) in 1972 in Least developed countries to that in Lower middle income?
Make the answer very short. 1.31. What is the ratio of the Aid flow from UN agencies (US$) of 1969 in Least developed countries to that in Middle East & North Africa (all income levels)?
Offer a terse response. 37.29. What is the ratio of the Aid flow from UN agencies (US$) of 1970 in Least developed countries to that in Middle East & North Africa (all income levels)?
Your answer should be compact. 28.24. What is the ratio of the Aid flow from UN agencies (US$) of 1971 in Least developed countries to that in Middle East & North Africa (all income levels)?
Provide a succinct answer. 35.07. What is the ratio of the Aid flow from UN agencies (US$) of 1972 in Least developed countries to that in Middle East & North Africa (all income levels)?
Offer a very short reply. 41.15. What is the ratio of the Aid flow from UN agencies (US$) in 1969 in Low & middle income to that in Low income?
Provide a short and direct response. 1.93. What is the ratio of the Aid flow from UN agencies (US$) of 1970 in Low & middle income to that in Low income?
Provide a succinct answer. 2.34. What is the ratio of the Aid flow from UN agencies (US$) in 1971 in Low & middle income to that in Low income?
Your answer should be very brief. 2.28. What is the ratio of the Aid flow from UN agencies (US$) of 1972 in Low & middle income to that in Low income?
Provide a succinct answer. 4.64. What is the ratio of the Aid flow from UN agencies (US$) of 1969 in Low & middle income to that in Lower middle income?
Offer a very short reply. 4.53. What is the ratio of the Aid flow from UN agencies (US$) of 1970 in Low & middle income to that in Lower middle income?
Make the answer very short. 3.83. What is the ratio of the Aid flow from UN agencies (US$) in 1971 in Low & middle income to that in Lower middle income?
Offer a very short reply. 4.1. What is the ratio of the Aid flow from UN agencies (US$) of 1972 in Low & middle income to that in Lower middle income?
Your answer should be very brief. 1.53. What is the ratio of the Aid flow from UN agencies (US$) in 1969 in Low & middle income to that in Middle East & North Africa (all income levels)?
Give a very brief answer. 54. What is the ratio of the Aid flow from UN agencies (US$) in 1970 in Low & middle income to that in Middle East & North Africa (all income levels)?
Offer a terse response. 45.12. What is the ratio of the Aid flow from UN agencies (US$) in 1971 in Low & middle income to that in Middle East & North Africa (all income levels)?
Offer a terse response. 62.14. What is the ratio of the Aid flow from UN agencies (US$) in 1972 in Low & middle income to that in Middle East & North Africa (all income levels)?
Ensure brevity in your answer.  48.07. What is the ratio of the Aid flow from UN agencies (US$) of 1969 in Low income to that in Lower middle income?
Keep it short and to the point. 2.35. What is the ratio of the Aid flow from UN agencies (US$) in 1970 in Low income to that in Lower middle income?
Make the answer very short. 1.64. What is the ratio of the Aid flow from UN agencies (US$) in 1971 in Low income to that in Lower middle income?
Offer a very short reply. 1.8. What is the ratio of the Aid flow from UN agencies (US$) of 1972 in Low income to that in Lower middle income?
Give a very brief answer. 0.33. What is the ratio of the Aid flow from UN agencies (US$) in 1969 in Low income to that in Middle East & North Africa (all income levels)?
Your response must be concise. 28. What is the ratio of the Aid flow from UN agencies (US$) in 1970 in Low income to that in Middle East & North Africa (all income levels)?
Ensure brevity in your answer.  19.29. What is the ratio of the Aid flow from UN agencies (US$) in 1971 in Low income to that in Middle East & North Africa (all income levels)?
Provide a short and direct response. 27.29. What is the ratio of the Aid flow from UN agencies (US$) of 1972 in Low income to that in Middle East & North Africa (all income levels)?
Ensure brevity in your answer.  10.35. What is the ratio of the Aid flow from UN agencies (US$) in 1969 in Lower middle income to that in Middle East & North Africa (all income levels)?
Ensure brevity in your answer.  11.93. What is the ratio of the Aid flow from UN agencies (US$) in 1970 in Lower middle income to that in Middle East & North Africa (all income levels)?
Ensure brevity in your answer.  11.76. What is the ratio of the Aid flow from UN agencies (US$) in 1971 in Lower middle income to that in Middle East & North Africa (all income levels)?
Ensure brevity in your answer.  15.14. What is the ratio of the Aid flow from UN agencies (US$) of 1972 in Lower middle income to that in Middle East & North Africa (all income levels)?
Ensure brevity in your answer.  31.46. What is the difference between the highest and the second highest Aid flow from UN agencies (US$) in 1969?
Give a very brief answer. 2.34e+06. What is the difference between the highest and the second highest Aid flow from UN agencies (US$) in 1970?
Provide a succinct answer. 2.87e+06. What is the difference between the highest and the second highest Aid flow from UN agencies (US$) of 1971?
Offer a terse response. 3.79e+06. What is the difference between the highest and the second highest Aid flow from UN agencies (US$) of 1972?
Offer a terse response. 3.18e+06. What is the difference between the highest and the lowest Aid flow from UN agencies (US$) of 1969?
Provide a succinct answer. 7.42e+06. What is the difference between the highest and the lowest Aid flow from UN agencies (US$) in 1970?
Offer a very short reply. 7.50e+06. What is the difference between the highest and the lowest Aid flow from UN agencies (US$) in 1971?
Provide a succinct answer. 8.56e+06. What is the difference between the highest and the lowest Aid flow from UN agencies (US$) of 1972?
Offer a very short reply. 2.18e+07. 